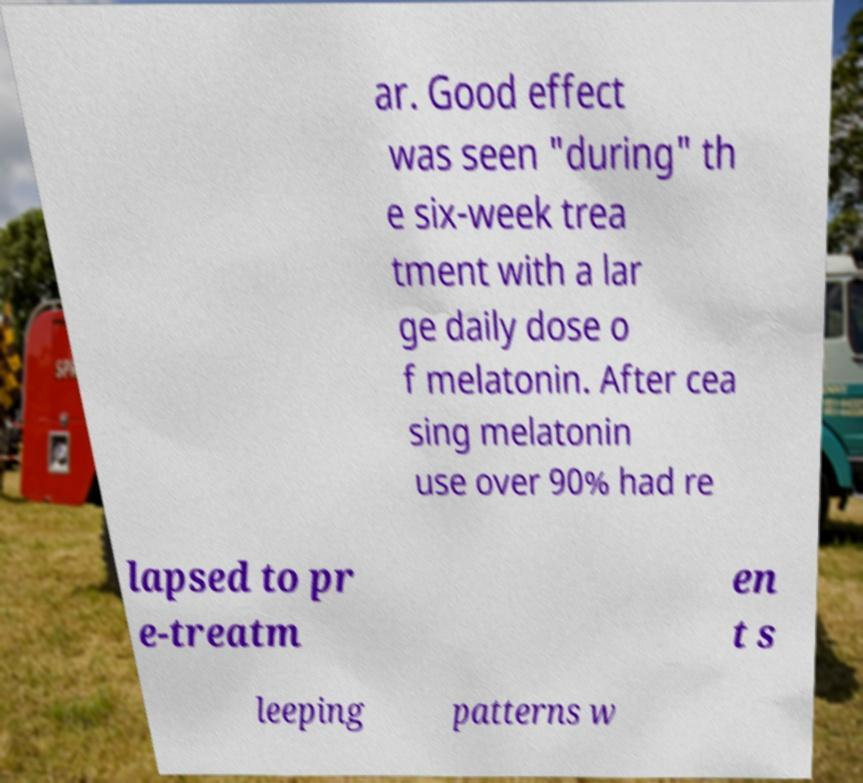Can you read and provide the text displayed in the image?This photo seems to have some interesting text. Can you extract and type it out for me? ar. Good effect was seen "during" th e six-week trea tment with a lar ge daily dose o f melatonin. After cea sing melatonin use over 90% had re lapsed to pr e-treatm en t s leeping patterns w 